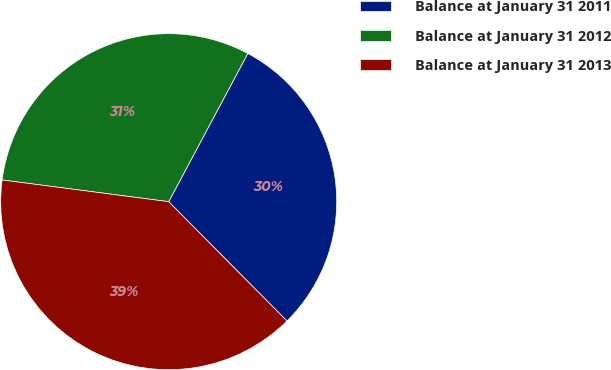Convert chart. <chart><loc_0><loc_0><loc_500><loc_500><pie_chart><fcel>Balance at January 31 2011<fcel>Balance at January 31 2012<fcel>Balance at January 31 2013<nl><fcel>29.77%<fcel>30.74%<fcel>39.49%<nl></chart> 